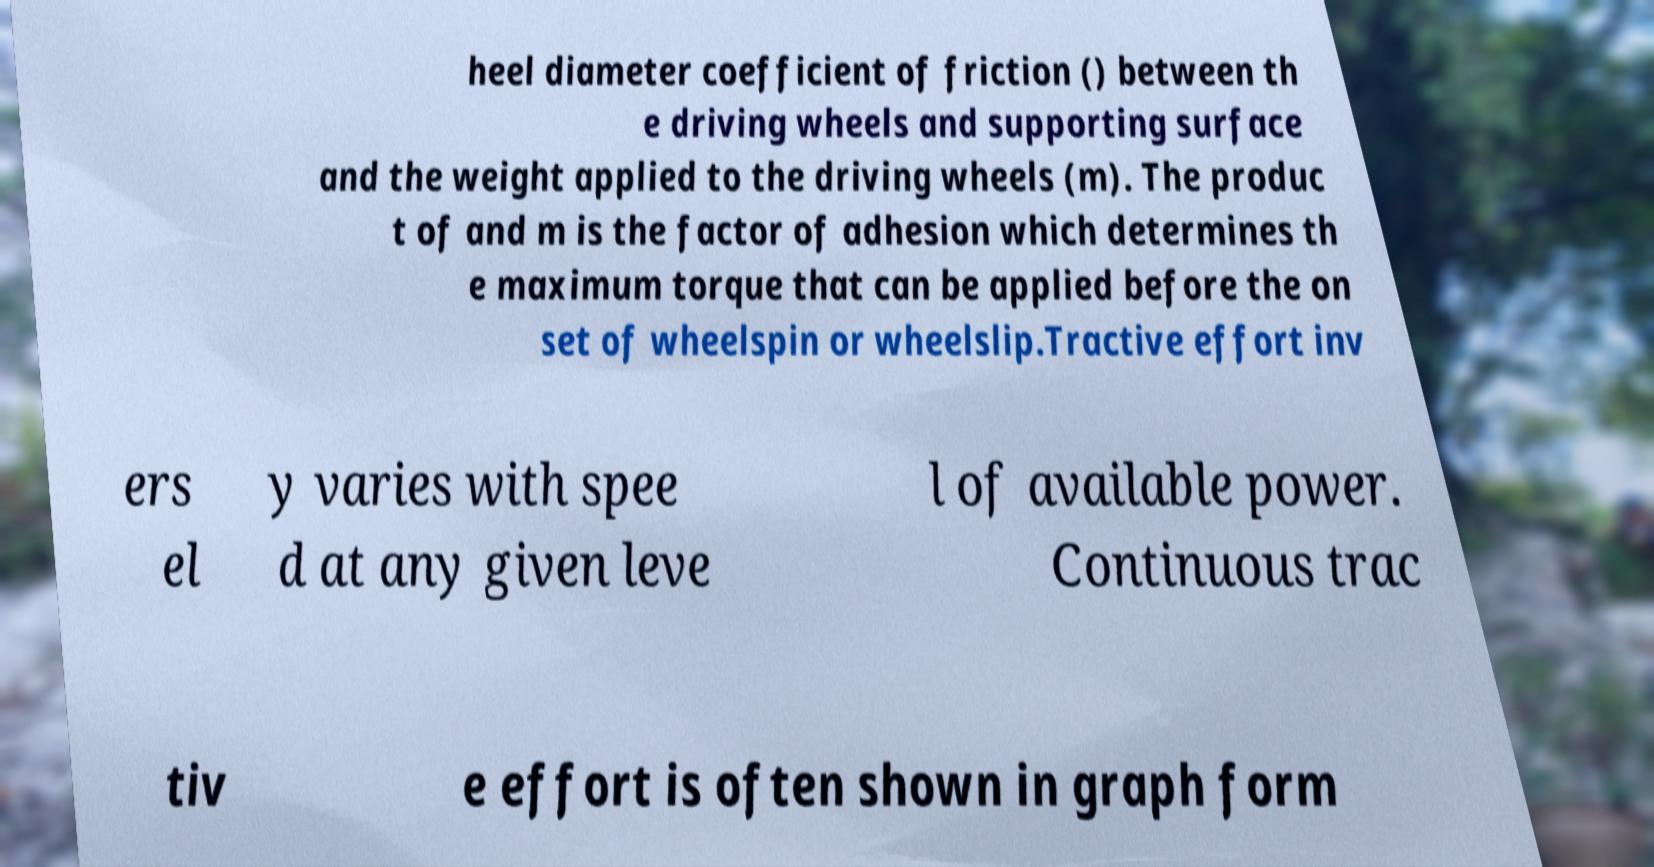What messages or text are displayed in this image? I need them in a readable, typed format. heel diameter coefficient of friction () between th e driving wheels and supporting surface and the weight applied to the driving wheels (m). The produc t of and m is the factor of adhesion which determines th e maximum torque that can be applied before the on set of wheelspin or wheelslip.Tractive effort inv ers el y varies with spee d at any given leve l of available power. Continuous trac tiv e effort is often shown in graph form 